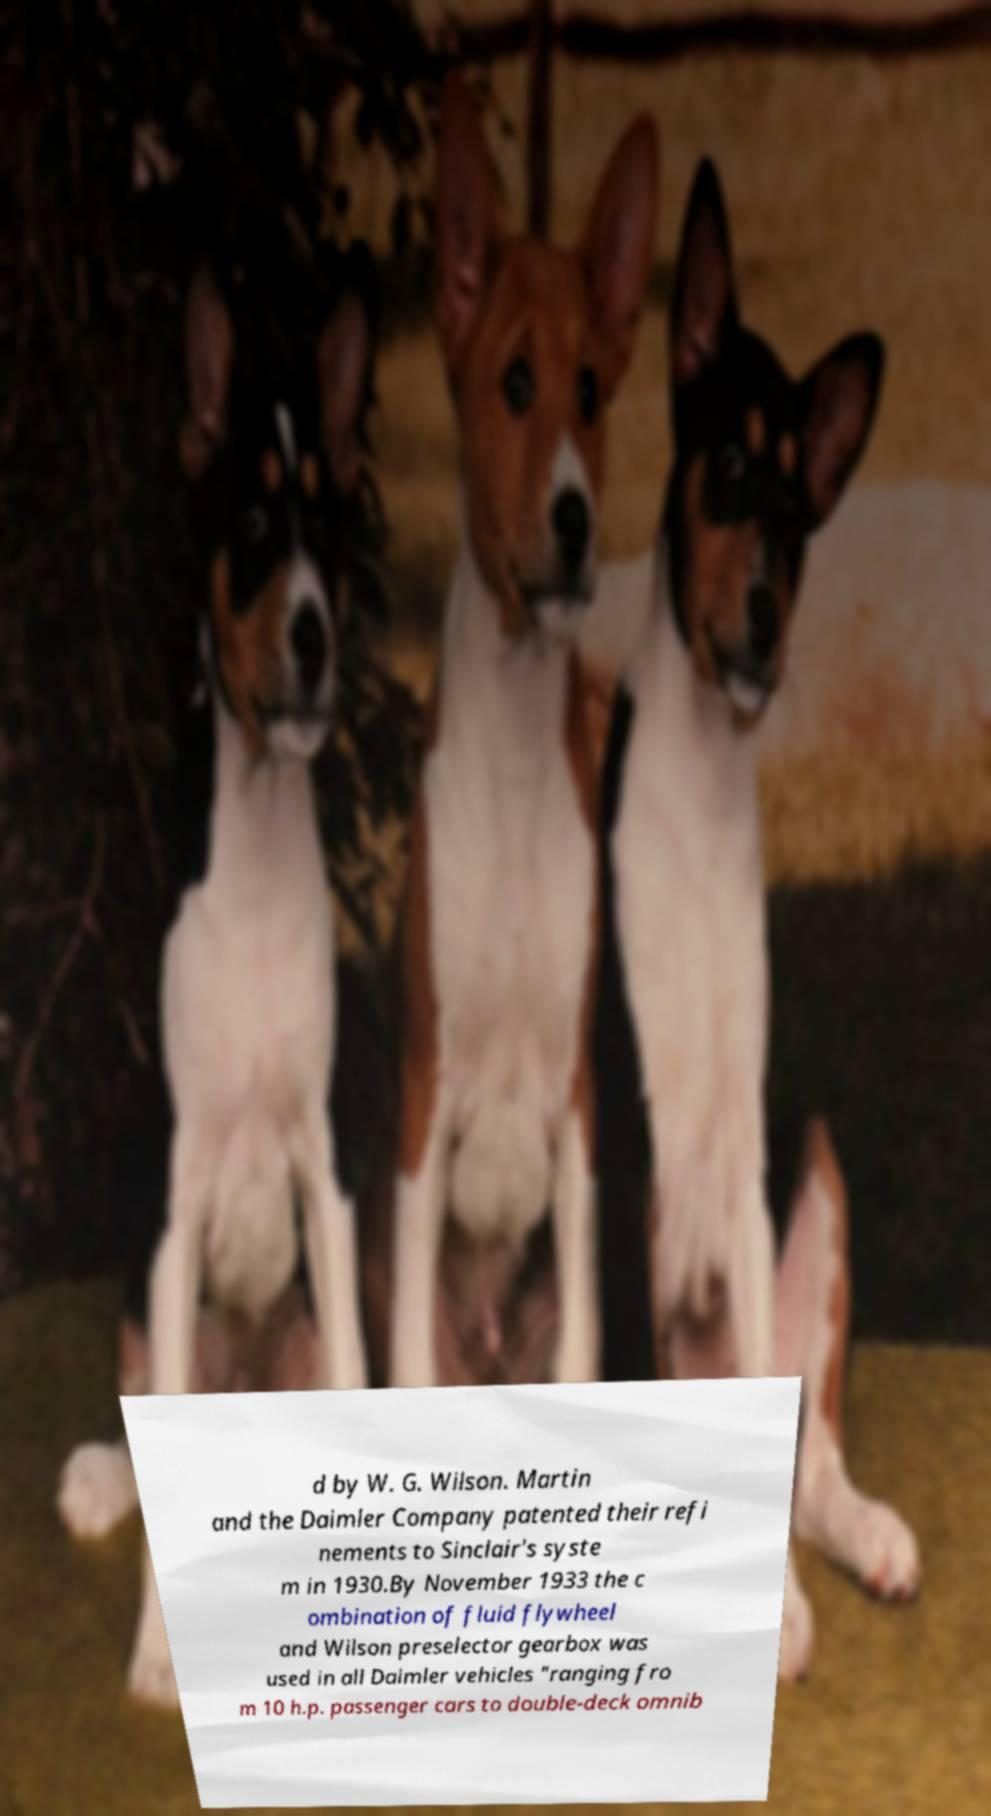For documentation purposes, I need the text within this image transcribed. Could you provide that? d by W. G. Wilson. Martin and the Daimler Company patented their refi nements to Sinclair's syste m in 1930.By November 1933 the c ombination of fluid flywheel and Wilson preselector gearbox was used in all Daimler vehicles "ranging fro m 10 h.p. passenger cars to double-deck omnib 